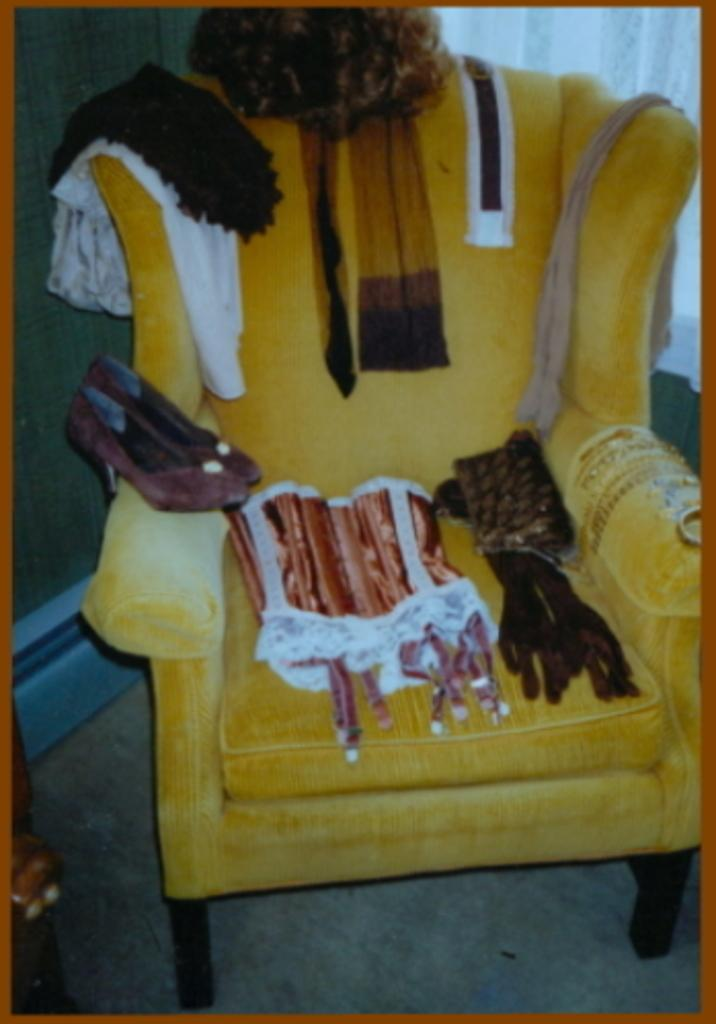What is placed on the floor in the image? There is a chair on the floor in the image. What is placed on the chair? Footwear and clothes are on the chair. Are there any other objects present on the chair? Yes, there are objects on the chair. What can be seen in the background of the image? There is a curtain and a wall visible in the background of the image. What type of jam is being spread on the chain in the image? There is no jam or chain present in the image. How is the lift being used in the image? There is no lift present in the image. 